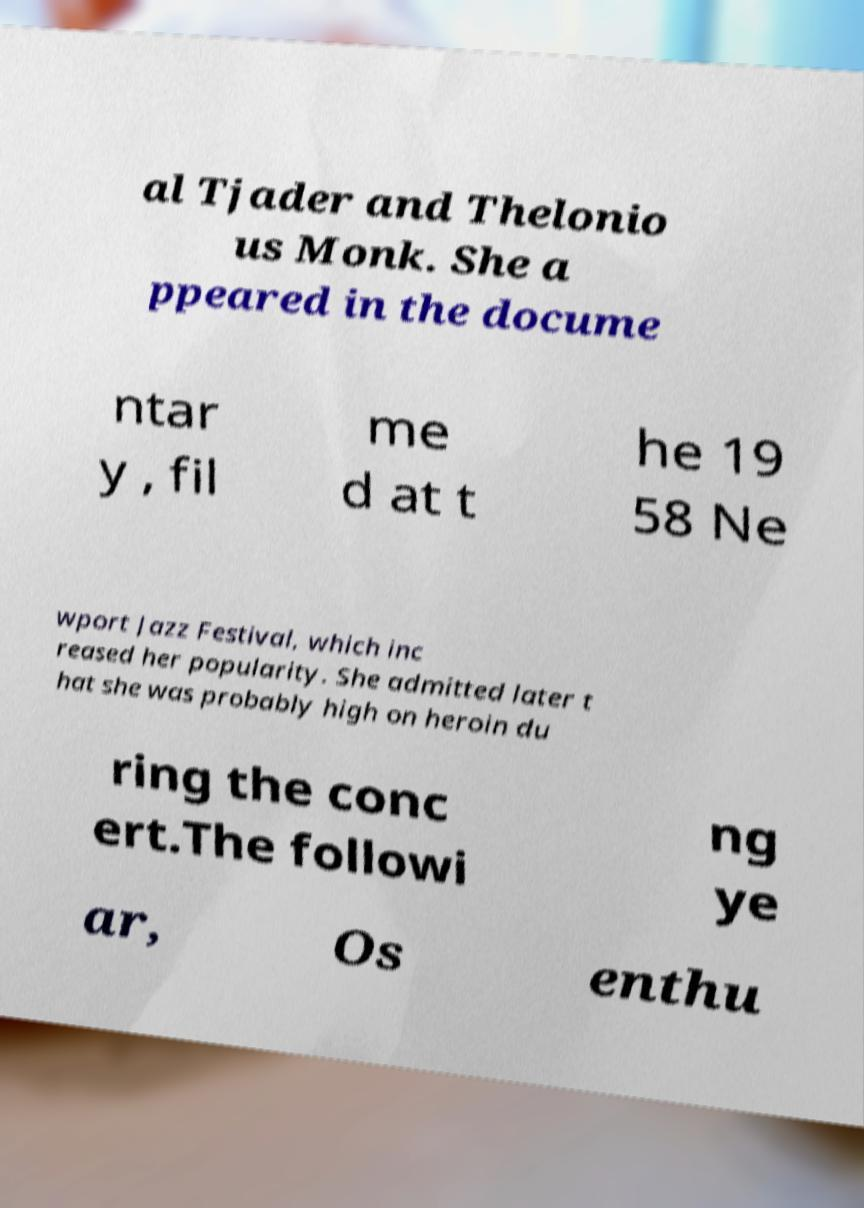Could you extract and type out the text from this image? al Tjader and Thelonio us Monk. She a ppeared in the docume ntar y , fil me d at t he 19 58 Ne wport Jazz Festival, which inc reased her popularity. She admitted later t hat she was probably high on heroin du ring the conc ert.The followi ng ye ar, Os enthu 